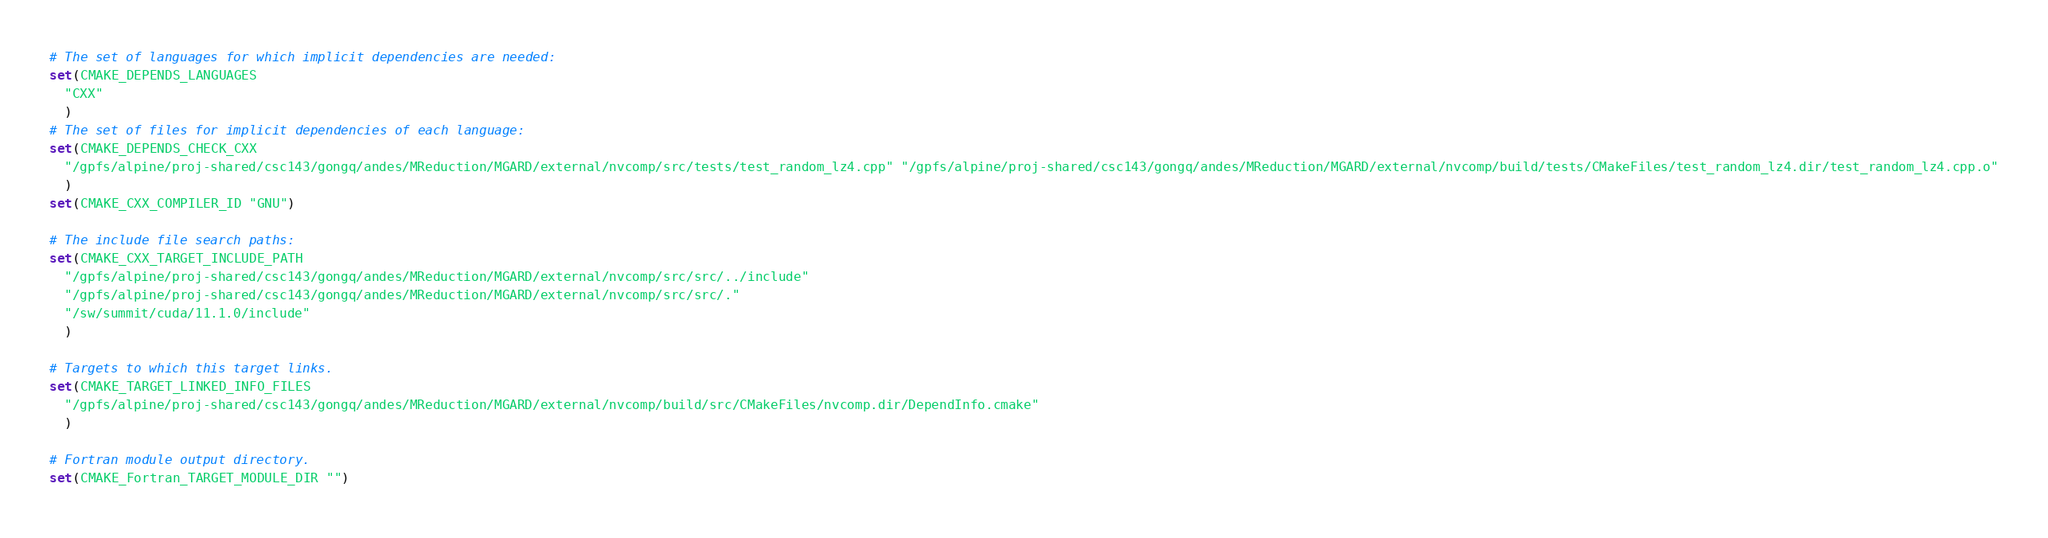<code> <loc_0><loc_0><loc_500><loc_500><_CMake_># The set of languages for which implicit dependencies are needed:
set(CMAKE_DEPENDS_LANGUAGES
  "CXX"
  )
# The set of files for implicit dependencies of each language:
set(CMAKE_DEPENDS_CHECK_CXX
  "/gpfs/alpine/proj-shared/csc143/gongq/andes/MReduction/MGARD/external/nvcomp/src/tests/test_random_lz4.cpp" "/gpfs/alpine/proj-shared/csc143/gongq/andes/MReduction/MGARD/external/nvcomp/build/tests/CMakeFiles/test_random_lz4.dir/test_random_lz4.cpp.o"
  )
set(CMAKE_CXX_COMPILER_ID "GNU")

# The include file search paths:
set(CMAKE_CXX_TARGET_INCLUDE_PATH
  "/gpfs/alpine/proj-shared/csc143/gongq/andes/MReduction/MGARD/external/nvcomp/src/src/../include"
  "/gpfs/alpine/proj-shared/csc143/gongq/andes/MReduction/MGARD/external/nvcomp/src/src/."
  "/sw/summit/cuda/11.1.0/include"
  )

# Targets to which this target links.
set(CMAKE_TARGET_LINKED_INFO_FILES
  "/gpfs/alpine/proj-shared/csc143/gongq/andes/MReduction/MGARD/external/nvcomp/build/src/CMakeFiles/nvcomp.dir/DependInfo.cmake"
  )

# Fortran module output directory.
set(CMAKE_Fortran_TARGET_MODULE_DIR "")
</code> 